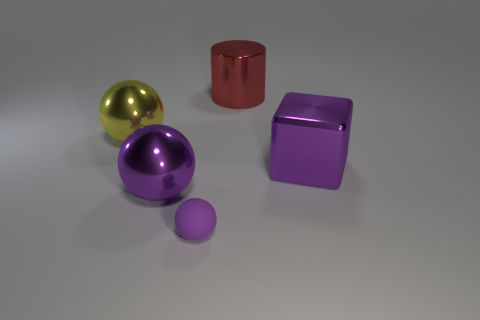There is a sphere that is the same color as the small matte object; what size is it?
Provide a succinct answer. Large. What is the size of the purple ball that is the same material as the cylinder?
Provide a succinct answer. Large. There is a metallic object that is left of the big shiny thing in front of the large purple cube; what is its shape?
Offer a very short reply. Sphere. What number of purple objects are either blocks or large spheres?
Offer a very short reply. 2. There is a thing that is to the left of the purple metallic thing that is to the left of the large cylinder; are there any cylinders that are in front of it?
Offer a very short reply. No. There is a shiny object that is the same color as the large metal cube; what shape is it?
Your answer should be very brief. Sphere. Is there any other thing that has the same material as the large yellow object?
Give a very brief answer. Yes. What number of big things are either purple matte objects or metal things?
Provide a short and direct response. 4. Does the big object behind the large yellow metal ball have the same shape as the tiny rubber thing?
Offer a terse response. No. Are there fewer red spheres than big yellow shiny things?
Offer a very short reply. Yes. 